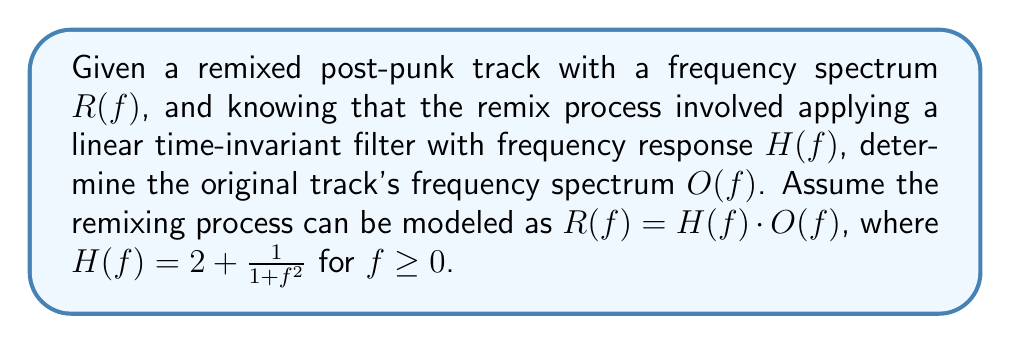Help me with this question. To solve this inverse problem and recover the original track's frequency spectrum, we need to follow these steps:

1) We know that $R(f) = H(f) \cdot O(f)$

2) To find $O(f)$, we need to divide both sides by $H(f)$:

   $$O(f) = \frac{R(f)}{H(f)}$$

3) We're given that $H(f) = 2 + \frac{1}{1+f^2}$ for $f \geq 0$

4) Substituting this into our equation:

   $$O(f) = \frac{R(f)}{2 + \frac{1}{1+f^2}}$$

5) To simplify this, let's multiply both numerator and denominator by $(1+f^2)$:

   $$O(f) = \frac{R(f)(1+f^2)}{2(1+f^2) + 1}$$

6) Simplifying the denominator:

   $$O(f) = \frac{R(f)(1+f^2)}{2f^2 + 3}$$

This gives us the formula to determine the original frequency spectrum $O(f)$ given the remixed spectrum $R(f)$.
Answer: $$O(f) = \frac{R(f)(1+f^2)}{2f^2 + 3}$$ 